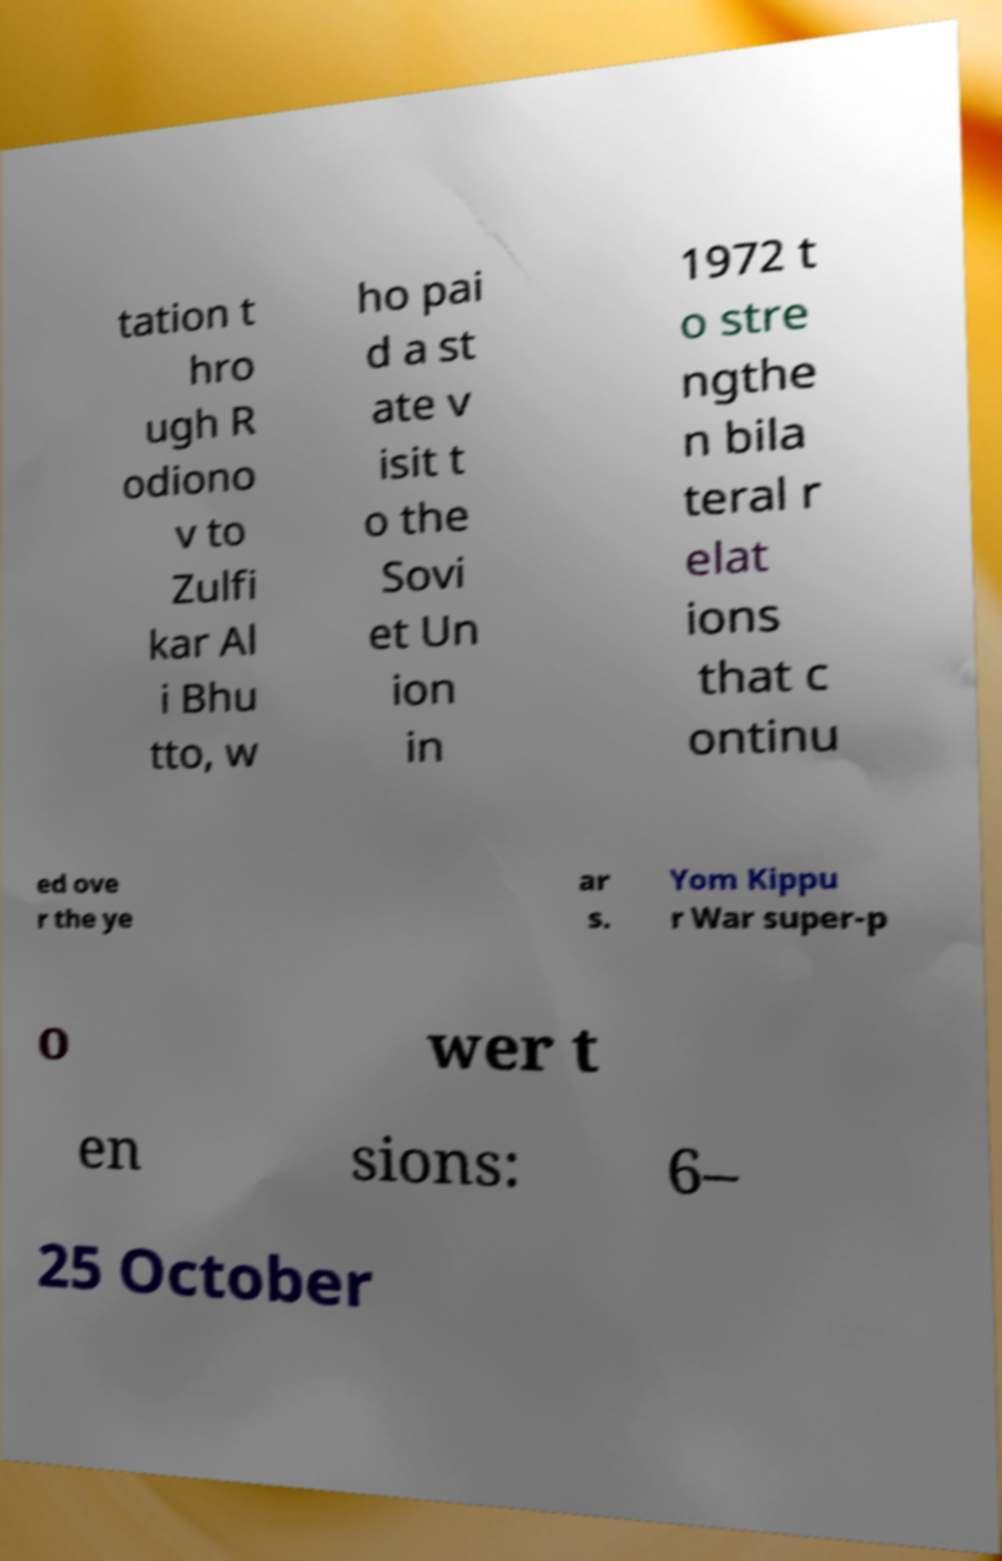For documentation purposes, I need the text within this image transcribed. Could you provide that? tation t hro ugh R odiono v to Zulfi kar Al i Bhu tto, w ho pai d a st ate v isit t o the Sovi et Un ion in 1972 t o stre ngthe n bila teral r elat ions that c ontinu ed ove r the ye ar s. Yom Kippu r War super-p o wer t en sions: 6– 25 October 